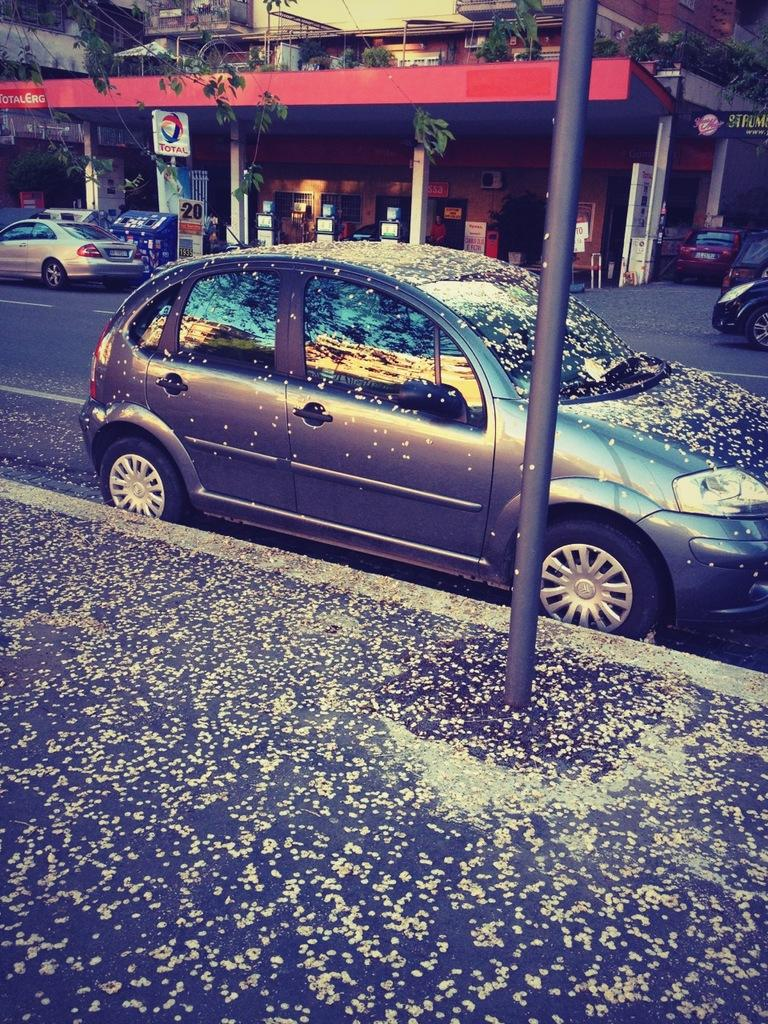What is the main subject in the center of the image? There is a car in the center of the image. Where is the car located? The car is on the road. What can be seen in the background of the image? There are buildings, pillars, cars, trees, plants, and a board in the background of the image. How many owls are perched on the branches in the image? There are no owls or branches present in the image. 